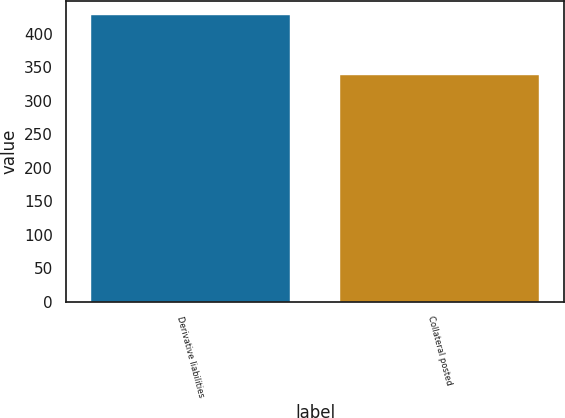<chart> <loc_0><loc_0><loc_500><loc_500><bar_chart><fcel>Derivative liabilities<fcel>Collateral posted<nl><fcel>428<fcel>339<nl></chart> 